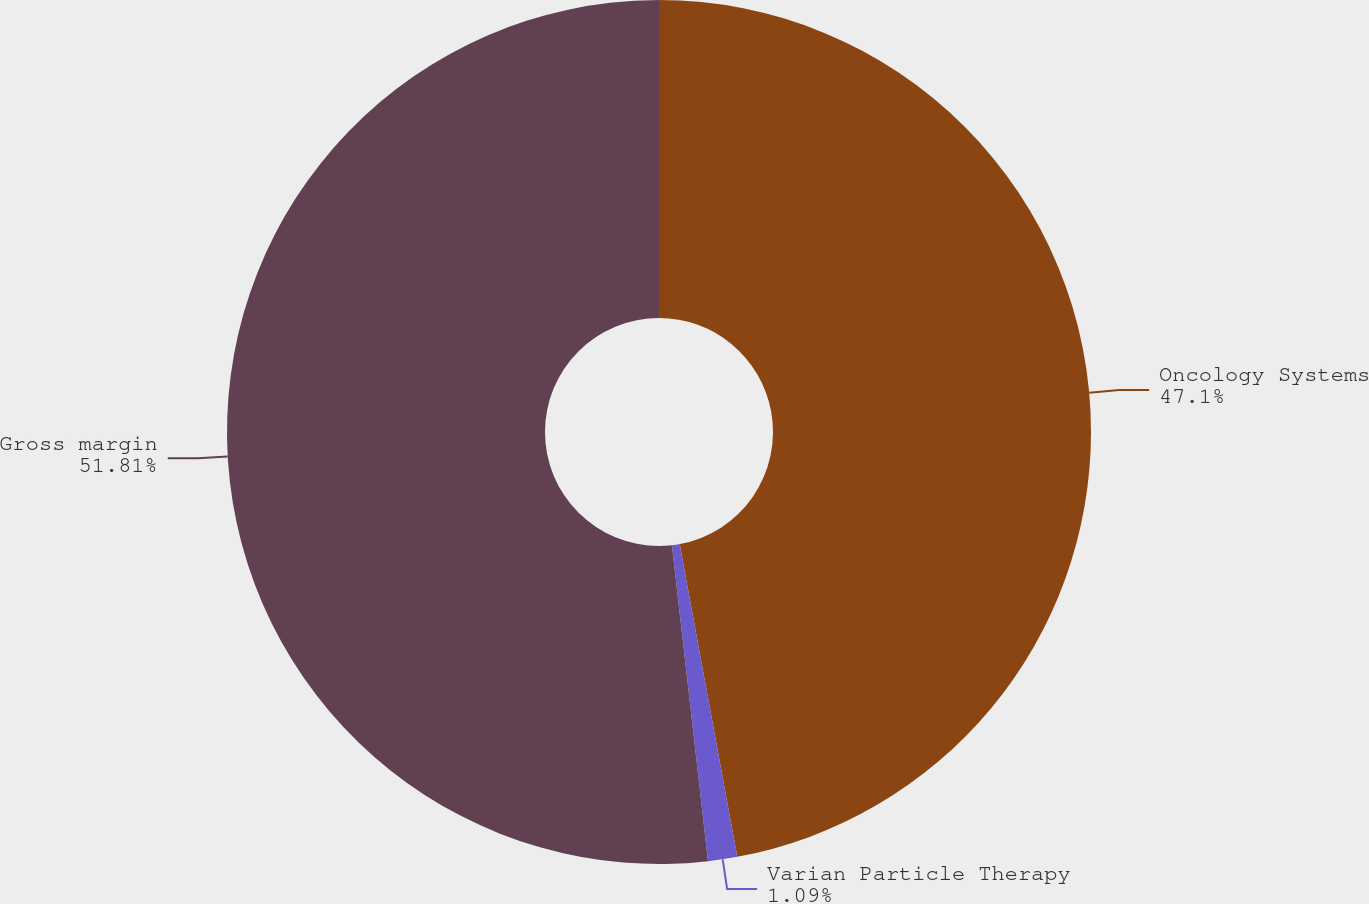Convert chart. <chart><loc_0><loc_0><loc_500><loc_500><pie_chart><fcel>Oncology Systems<fcel>Varian Particle Therapy<fcel>Gross margin<nl><fcel>47.1%<fcel>1.09%<fcel>51.81%<nl></chart> 